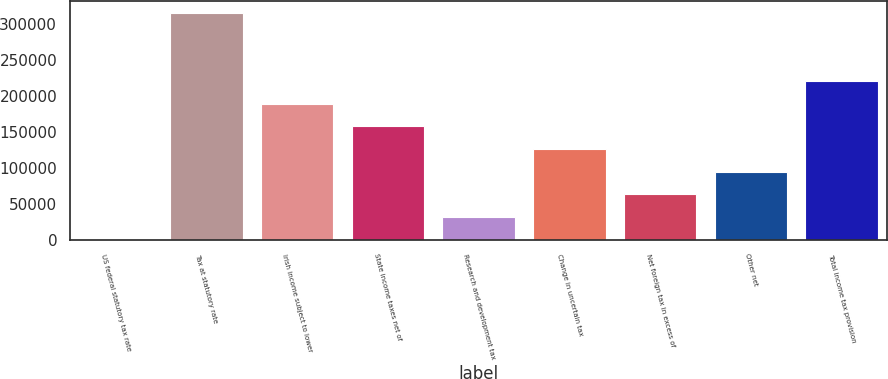Convert chart. <chart><loc_0><loc_0><loc_500><loc_500><bar_chart><fcel>US federal statutory tax rate<fcel>Tax at statutory rate<fcel>Irish income subject to lower<fcel>State income taxes net of<fcel>Research and development tax<fcel>Change in uncertain tax<fcel>Net foreign tax in excess of<fcel>Other net<fcel>Total income tax provision<nl><fcel>35<fcel>315583<fcel>189364<fcel>157809<fcel>31589.8<fcel>126254<fcel>63144.6<fcel>94699.4<fcel>220919<nl></chart> 